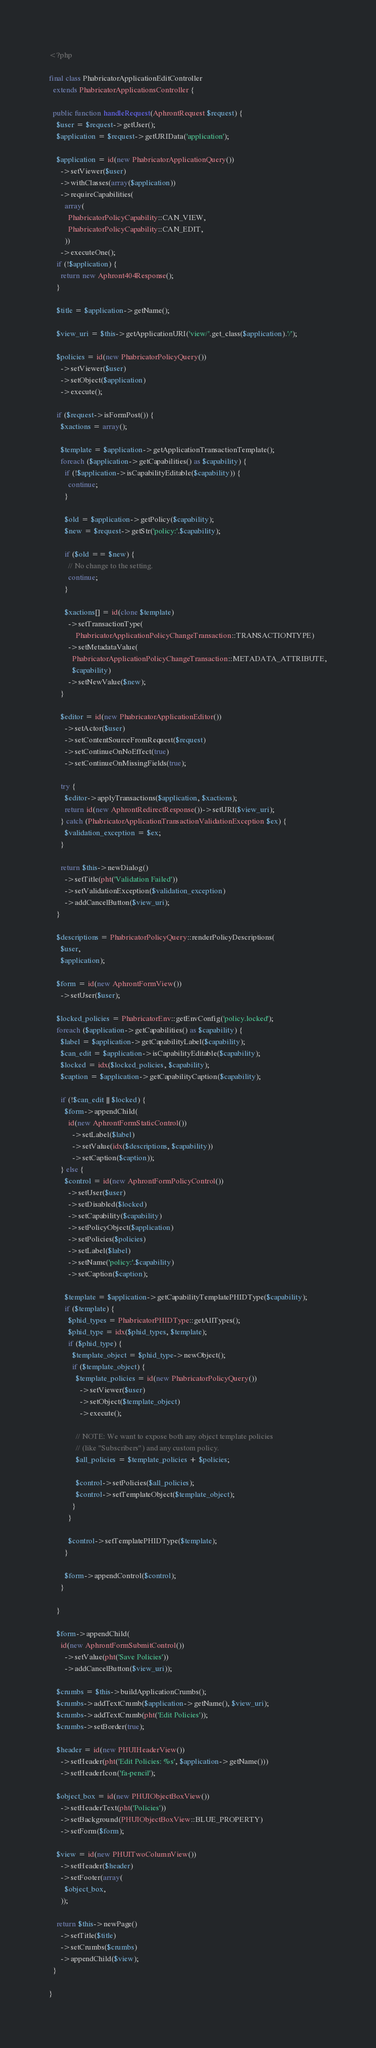<code> <loc_0><loc_0><loc_500><loc_500><_PHP_><?php

final class PhabricatorApplicationEditController
  extends PhabricatorApplicationsController {

  public function handleRequest(AphrontRequest $request) {
    $user = $request->getUser();
    $application = $request->getURIData('application');

    $application = id(new PhabricatorApplicationQuery())
      ->setViewer($user)
      ->withClasses(array($application))
      ->requireCapabilities(
        array(
          PhabricatorPolicyCapability::CAN_VIEW,
          PhabricatorPolicyCapability::CAN_EDIT,
        ))
      ->executeOne();
    if (!$application) {
      return new Aphront404Response();
    }

    $title = $application->getName();

    $view_uri = $this->getApplicationURI('view/'.get_class($application).'/');

    $policies = id(new PhabricatorPolicyQuery())
      ->setViewer($user)
      ->setObject($application)
      ->execute();

    if ($request->isFormPost()) {
      $xactions = array();

      $template = $application->getApplicationTransactionTemplate();
      foreach ($application->getCapabilities() as $capability) {
        if (!$application->isCapabilityEditable($capability)) {
          continue;
        }

        $old = $application->getPolicy($capability);
        $new = $request->getStr('policy:'.$capability);

        if ($old == $new) {
          // No change to the setting.
          continue;
        }

        $xactions[] = id(clone $template)
          ->setTransactionType(
              PhabricatorApplicationPolicyChangeTransaction::TRANSACTIONTYPE)
          ->setMetadataValue(
            PhabricatorApplicationPolicyChangeTransaction::METADATA_ATTRIBUTE,
            $capability)
          ->setNewValue($new);
      }

      $editor = id(new PhabricatorApplicationEditor())
        ->setActor($user)
        ->setContentSourceFromRequest($request)
        ->setContinueOnNoEffect(true)
        ->setContinueOnMissingFields(true);

      try {
        $editor->applyTransactions($application, $xactions);
        return id(new AphrontRedirectResponse())->setURI($view_uri);
      } catch (PhabricatorApplicationTransactionValidationException $ex) {
        $validation_exception = $ex;
      }

      return $this->newDialog()
        ->setTitle(pht('Validation Failed'))
        ->setValidationException($validation_exception)
        ->addCancelButton($view_uri);
    }

    $descriptions = PhabricatorPolicyQuery::renderPolicyDescriptions(
      $user,
      $application);

    $form = id(new AphrontFormView())
      ->setUser($user);

    $locked_policies = PhabricatorEnv::getEnvConfig('policy.locked');
    foreach ($application->getCapabilities() as $capability) {
      $label = $application->getCapabilityLabel($capability);
      $can_edit = $application->isCapabilityEditable($capability);
      $locked = idx($locked_policies, $capability);
      $caption = $application->getCapabilityCaption($capability);

      if (!$can_edit || $locked) {
        $form->appendChild(
          id(new AphrontFormStaticControl())
            ->setLabel($label)
            ->setValue(idx($descriptions, $capability))
            ->setCaption($caption));
      } else {
        $control = id(new AphrontFormPolicyControl())
          ->setUser($user)
          ->setDisabled($locked)
          ->setCapability($capability)
          ->setPolicyObject($application)
          ->setPolicies($policies)
          ->setLabel($label)
          ->setName('policy:'.$capability)
          ->setCaption($caption);

        $template = $application->getCapabilityTemplatePHIDType($capability);
        if ($template) {
          $phid_types = PhabricatorPHIDType::getAllTypes();
          $phid_type = idx($phid_types, $template);
          if ($phid_type) {
            $template_object = $phid_type->newObject();
            if ($template_object) {
              $template_policies = id(new PhabricatorPolicyQuery())
                ->setViewer($user)
                ->setObject($template_object)
                ->execute();

              // NOTE: We want to expose both any object template policies
              // (like "Subscribers") and any custom policy.
              $all_policies = $template_policies + $policies;

              $control->setPolicies($all_policies);
              $control->setTemplateObject($template_object);
            }
          }

          $control->setTemplatePHIDType($template);
        }

        $form->appendControl($control);
      }

    }

    $form->appendChild(
      id(new AphrontFormSubmitControl())
        ->setValue(pht('Save Policies'))
        ->addCancelButton($view_uri));

    $crumbs = $this->buildApplicationCrumbs();
    $crumbs->addTextCrumb($application->getName(), $view_uri);
    $crumbs->addTextCrumb(pht('Edit Policies'));
    $crumbs->setBorder(true);

    $header = id(new PHUIHeaderView())
      ->setHeader(pht('Edit Policies: %s', $application->getName()))
      ->setHeaderIcon('fa-pencil');

    $object_box = id(new PHUIObjectBoxView())
      ->setHeaderText(pht('Policies'))
      ->setBackground(PHUIObjectBoxView::BLUE_PROPERTY)
      ->setForm($form);

    $view = id(new PHUITwoColumnView())
      ->setHeader($header)
      ->setFooter(array(
        $object_box,
      ));

    return $this->newPage()
      ->setTitle($title)
      ->setCrumbs($crumbs)
      ->appendChild($view);
  }

}
</code> 